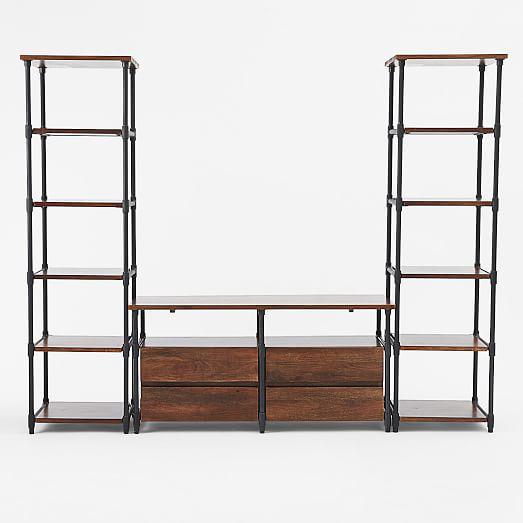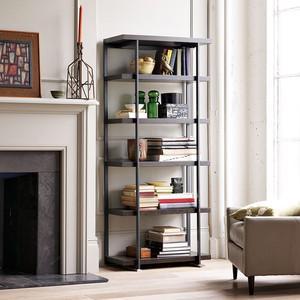The first image is the image on the left, the second image is the image on the right. Considering the images on both sides, is "One of the images shows a bookshelf that is empty." valid? Answer yes or no. Yes. The first image is the image on the left, the second image is the image on the right. Given the left and right images, does the statement "An image shows a completely empty set of shelves." hold true? Answer yes or no. Yes. 